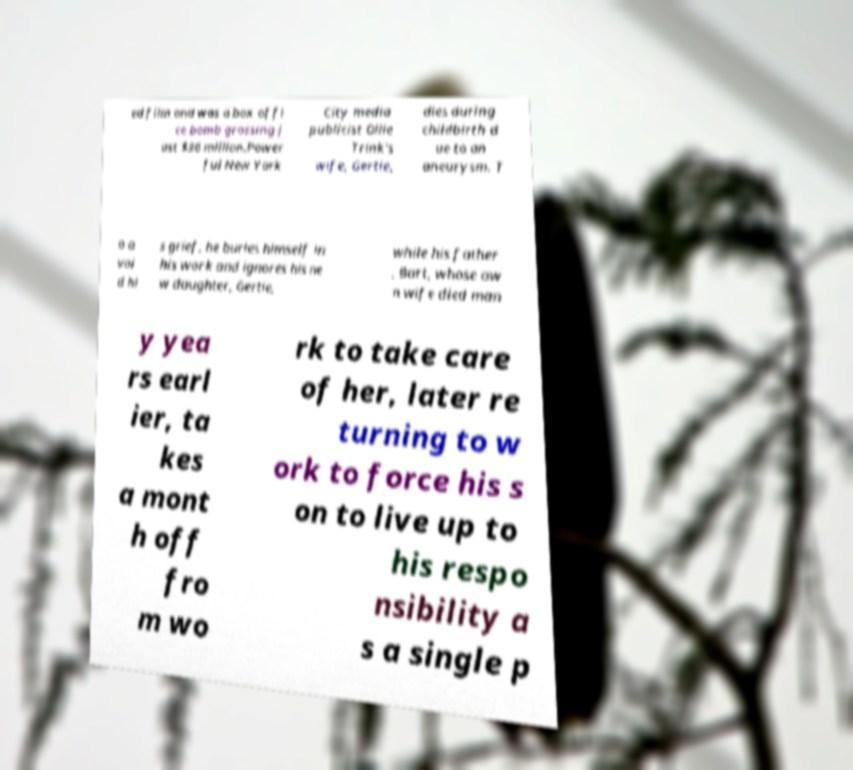Could you assist in decoding the text presented in this image and type it out clearly? ed film and was a box offi ce bomb grossing j ust $36 million.Power ful New York City media publicist Ollie Trink's wife, Gertie, dies during childbirth d ue to an aneurysm. T o a voi d hi s grief, he buries himself in his work and ignores his ne w daughter, Gertie, while his father , Bart, whose ow n wife died man y yea rs earl ier, ta kes a mont h off fro m wo rk to take care of her, later re turning to w ork to force his s on to live up to his respo nsibility a s a single p 